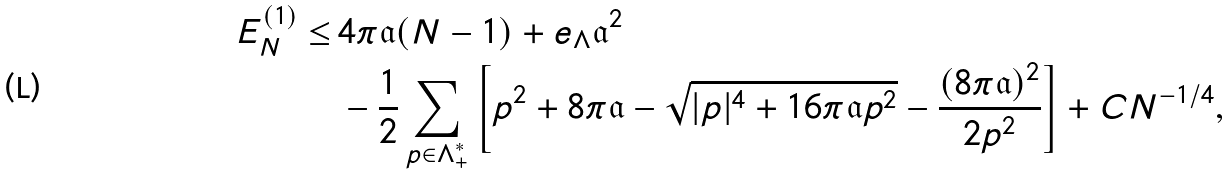<formula> <loc_0><loc_0><loc_500><loc_500>E _ { N } ^ { ( 1 ) } \leq \, & 4 \pi \mathfrak { a } ( N - 1 ) + e _ { \Lambda } \mathfrak { a } ^ { 2 } \\ & - \frac { 1 } { 2 } \sum _ { p \in \Lambda _ { + } ^ { * } } \left [ p ^ { 2 } + 8 \pi \mathfrak { a } - \sqrt { | p | ^ { 4 } + 1 6 \pi \mathfrak { a } p ^ { 2 } } - \frac { ( 8 \pi \mathfrak { a } ) ^ { 2 } } { 2 p ^ { 2 } } \right ] + C N ^ { - 1 / 4 } ,</formula> 